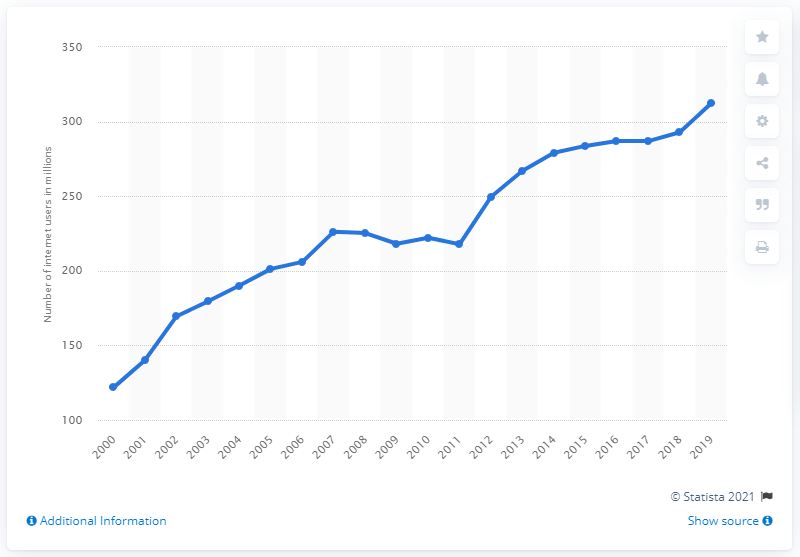Highlight a few significant elements in this photo. In 2019, there were approximately 312.32 million internet users in the United States who accessed the web. In 2017, there were 286.94 million internet users in the United States who accessed the web. 